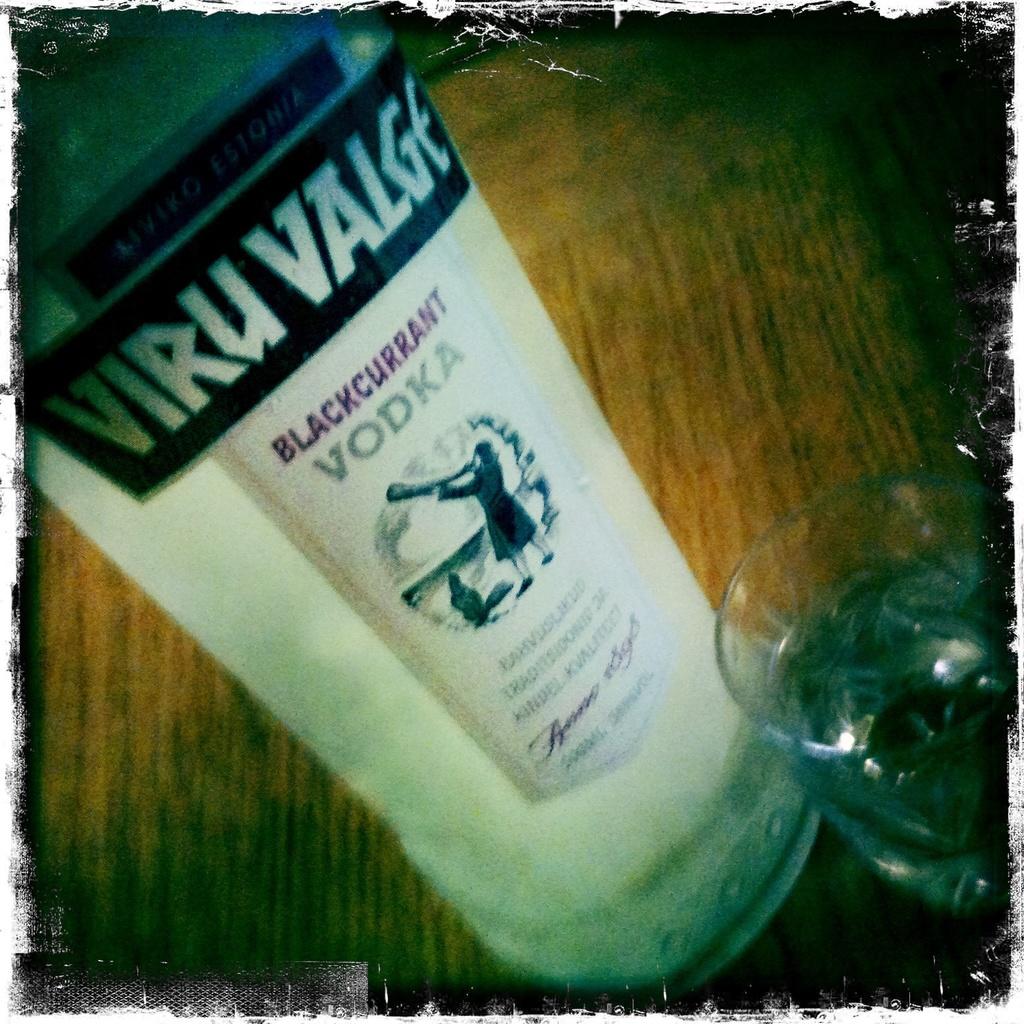What's the brand name on this vodka?
Your answer should be compact. Viru valge. 